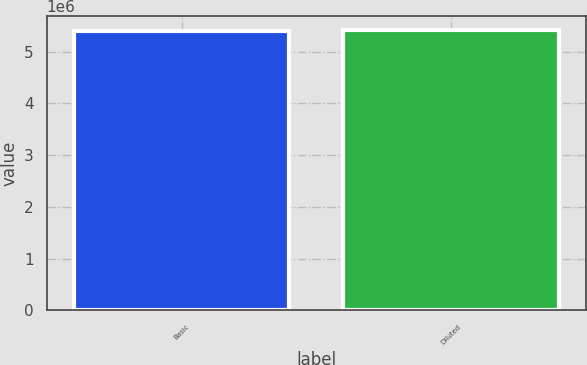<chart> <loc_0><loc_0><loc_500><loc_500><bar_chart><fcel>Basic<fcel>Diluted<nl><fcel>5.39695e+06<fcel>5.40847e+06<nl></chart> 